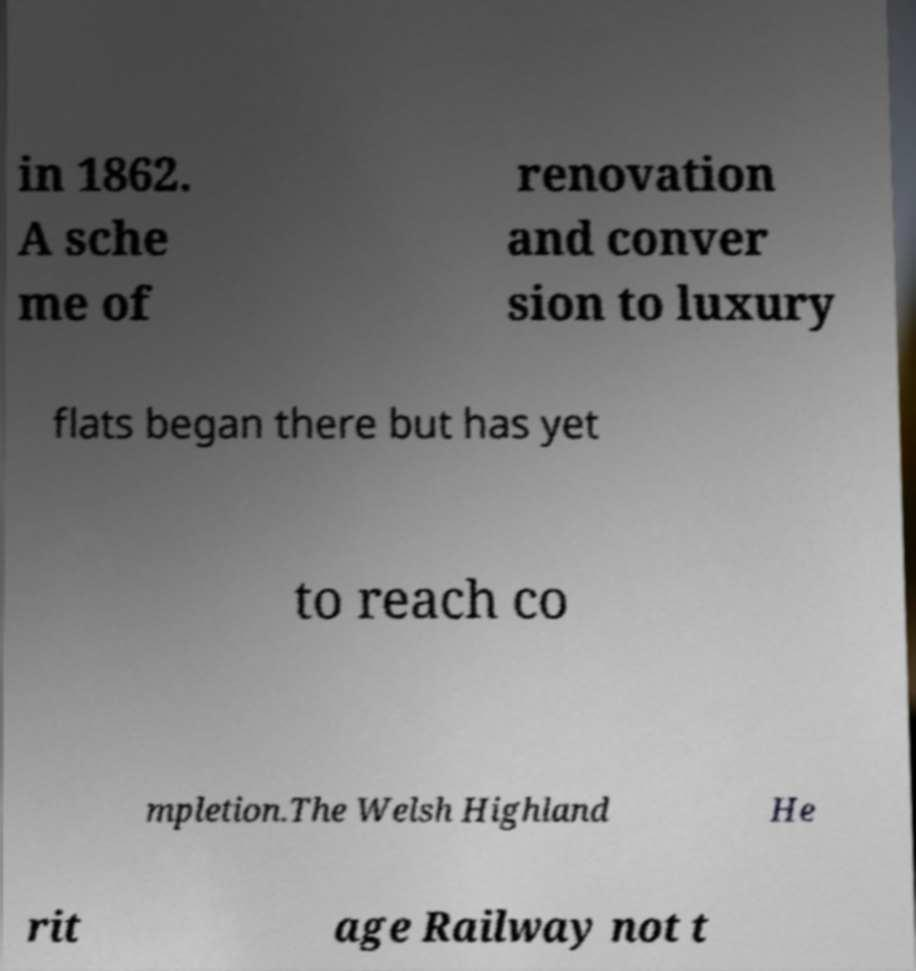What messages or text are displayed in this image? I need them in a readable, typed format. in 1862. A sche me of renovation and conver sion to luxury flats began there but has yet to reach co mpletion.The Welsh Highland He rit age Railway not t 